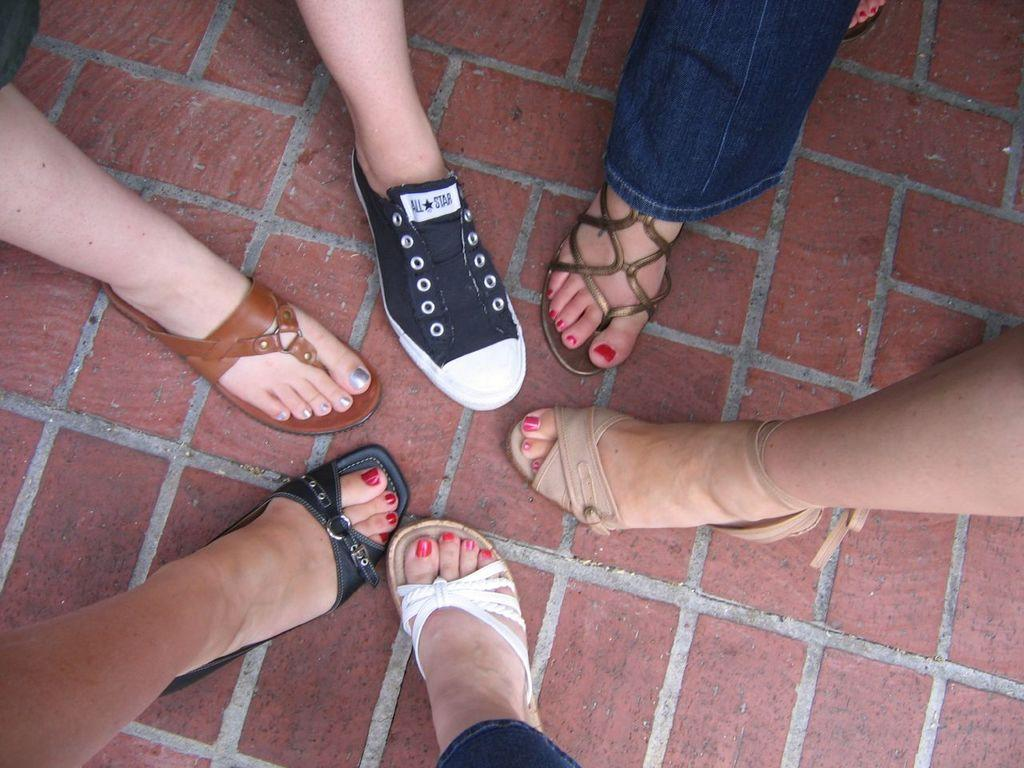What can be seen in the image related to people? There are legs of different people in the image. Can you describe the footwear of the people in the image? The footwear of the people is unique. What type of property can be seen in the image? There is no property visible in the image; it only shows legs and unique footwear. 